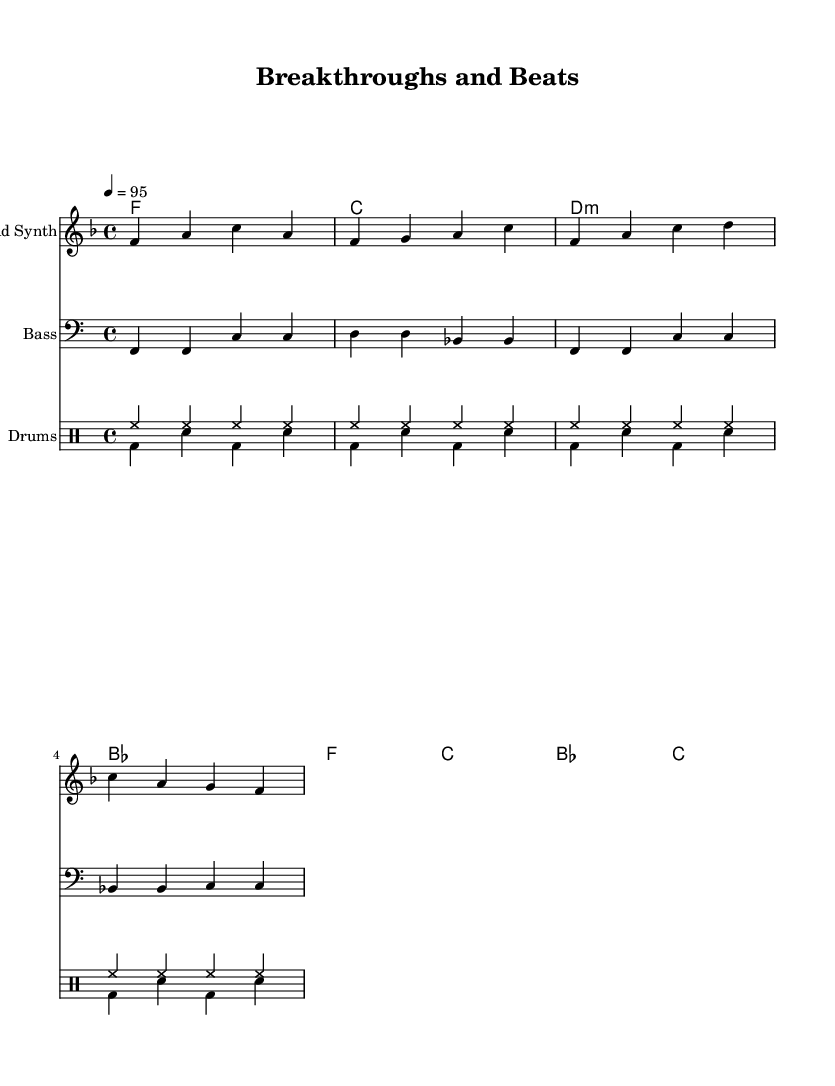What is the key signature of this music? The key signature is F major, which has one flat (B flat). This is indicated at the beginning of the staff in the sheet music.
Answer: F major What is the time signature of this music? The time signature is 4/4, which is shown at the beginning of the score; it indicates there are four beats per measure.
Answer: 4/4 What is the tempo marking for this piece? The tempo marking is 95 beats per minute as indicated just after the time signature, informing the performer of the speed at which to play.
Answer: 95 How many measures are there in the melody? The melody consists of four measures as shown visually in the staff, with each measure separated by vertical bar lines.
Answer: Four What type of drum pattern is used in this piece? The drum pattern combines a hi-hat pattern with a bass drum and snare pattern, typical of upbeat hip-hop tracks, and is specifically displayed in separate drum voices in the sheet music.
Answer: Dual drum patterns Which musical form is suggested by the sections in the score? The score suggests a repeating structure typical of hip-hop, where the melody and rhythmic patterns recur, creating a loop-like form that is common in this genre.
Answer: Repeating structure 